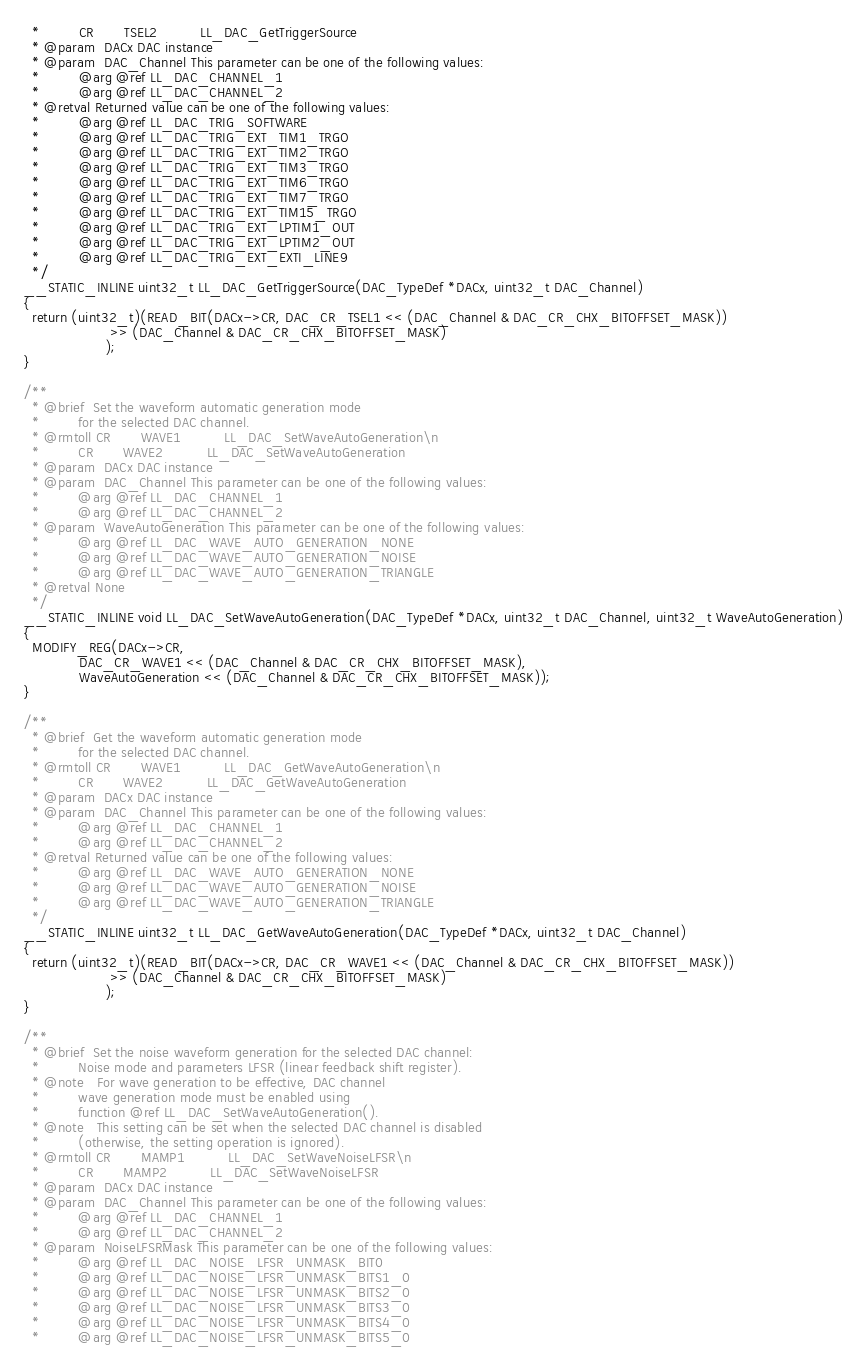Convert code to text. <code><loc_0><loc_0><loc_500><loc_500><_C_>  *         CR       TSEL2          LL_DAC_GetTriggerSource
  * @param  DACx DAC instance
  * @param  DAC_Channel This parameter can be one of the following values:
  *         @arg @ref LL_DAC_CHANNEL_1
  *         @arg @ref LL_DAC_CHANNEL_2
  * @retval Returned value can be one of the following values:
  *         @arg @ref LL_DAC_TRIG_SOFTWARE
  *         @arg @ref LL_DAC_TRIG_EXT_TIM1_TRGO
  *         @arg @ref LL_DAC_TRIG_EXT_TIM2_TRGO
  *         @arg @ref LL_DAC_TRIG_EXT_TIM3_TRGO
  *         @arg @ref LL_DAC_TRIG_EXT_TIM6_TRGO
  *         @arg @ref LL_DAC_TRIG_EXT_TIM7_TRGO
  *         @arg @ref LL_DAC_TRIG_EXT_TIM15_TRGO
  *         @arg @ref LL_DAC_TRIG_EXT_LPTIM1_OUT
  *         @arg @ref LL_DAC_TRIG_EXT_LPTIM2_OUT
  *         @arg @ref LL_DAC_TRIG_EXT_EXTI_LINE9
  */
__STATIC_INLINE uint32_t LL_DAC_GetTriggerSource(DAC_TypeDef *DACx, uint32_t DAC_Channel)
{
  return (uint32_t)(READ_BIT(DACx->CR, DAC_CR_TSEL1 << (DAC_Channel & DAC_CR_CHX_BITOFFSET_MASK))
                    >> (DAC_Channel & DAC_CR_CHX_BITOFFSET_MASK)
                   );
}

/**
  * @brief  Set the waveform automatic generation mode
  *         for the selected DAC channel.
  * @rmtoll CR       WAVE1          LL_DAC_SetWaveAutoGeneration\n
  *         CR       WAVE2          LL_DAC_SetWaveAutoGeneration
  * @param  DACx DAC instance
  * @param  DAC_Channel This parameter can be one of the following values:
  *         @arg @ref LL_DAC_CHANNEL_1
  *         @arg @ref LL_DAC_CHANNEL_2
  * @param  WaveAutoGeneration This parameter can be one of the following values:
  *         @arg @ref LL_DAC_WAVE_AUTO_GENERATION_NONE
  *         @arg @ref LL_DAC_WAVE_AUTO_GENERATION_NOISE
  *         @arg @ref LL_DAC_WAVE_AUTO_GENERATION_TRIANGLE
  * @retval None
  */
__STATIC_INLINE void LL_DAC_SetWaveAutoGeneration(DAC_TypeDef *DACx, uint32_t DAC_Channel, uint32_t WaveAutoGeneration)
{
  MODIFY_REG(DACx->CR,
             DAC_CR_WAVE1 << (DAC_Channel & DAC_CR_CHX_BITOFFSET_MASK),
             WaveAutoGeneration << (DAC_Channel & DAC_CR_CHX_BITOFFSET_MASK));
}

/**
  * @brief  Get the waveform automatic generation mode
  *         for the selected DAC channel.
  * @rmtoll CR       WAVE1          LL_DAC_GetWaveAutoGeneration\n
  *         CR       WAVE2          LL_DAC_GetWaveAutoGeneration
  * @param  DACx DAC instance
  * @param  DAC_Channel This parameter can be one of the following values:
  *         @arg @ref LL_DAC_CHANNEL_1
  *         @arg @ref LL_DAC_CHANNEL_2
  * @retval Returned value can be one of the following values:
  *         @arg @ref LL_DAC_WAVE_AUTO_GENERATION_NONE
  *         @arg @ref LL_DAC_WAVE_AUTO_GENERATION_NOISE
  *         @arg @ref LL_DAC_WAVE_AUTO_GENERATION_TRIANGLE
  */
__STATIC_INLINE uint32_t LL_DAC_GetWaveAutoGeneration(DAC_TypeDef *DACx, uint32_t DAC_Channel)
{
  return (uint32_t)(READ_BIT(DACx->CR, DAC_CR_WAVE1 << (DAC_Channel & DAC_CR_CHX_BITOFFSET_MASK))
                    >> (DAC_Channel & DAC_CR_CHX_BITOFFSET_MASK)
                   );
}

/**
  * @brief  Set the noise waveform generation for the selected DAC channel:
  *         Noise mode and parameters LFSR (linear feedback shift register).
  * @note   For wave generation to be effective, DAC channel
  *         wave generation mode must be enabled using
  *         function @ref LL_DAC_SetWaveAutoGeneration().
  * @note   This setting can be set when the selected DAC channel is disabled
  *         (otherwise, the setting operation is ignored).
  * @rmtoll CR       MAMP1          LL_DAC_SetWaveNoiseLFSR\n
  *         CR       MAMP2          LL_DAC_SetWaveNoiseLFSR
  * @param  DACx DAC instance
  * @param  DAC_Channel This parameter can be one of the following values:
  *         @arg @ref LL_DAC_CHANNEL_1
  *         @arg @ref LL_DAC_CHANNEL_2
  * @param  NoiseLFSRMask This parameter can be one of the following values:
  *         @arg @ref LL_DAC_NOISE_LFSR_UNMASK_BIT0
  *         @arg @ref LL_DAC_NOISE_LFSR_UNMASK_BITS1_0
  *         @arg @ref LL_DAC_NOISE_LFSR_UNMASK_BITS2_0
  *         @arg @ref LL_DAC_NOISE_LFSR_UNMASK_BITS3_0
  *         @arg @ref LL_DAC_NOISE_LFSR_UNMASK_BITS4_0
  *         @arg @ref LL_DAC_NOISE_LFSR_UNMASK_BITS5_0</code> 